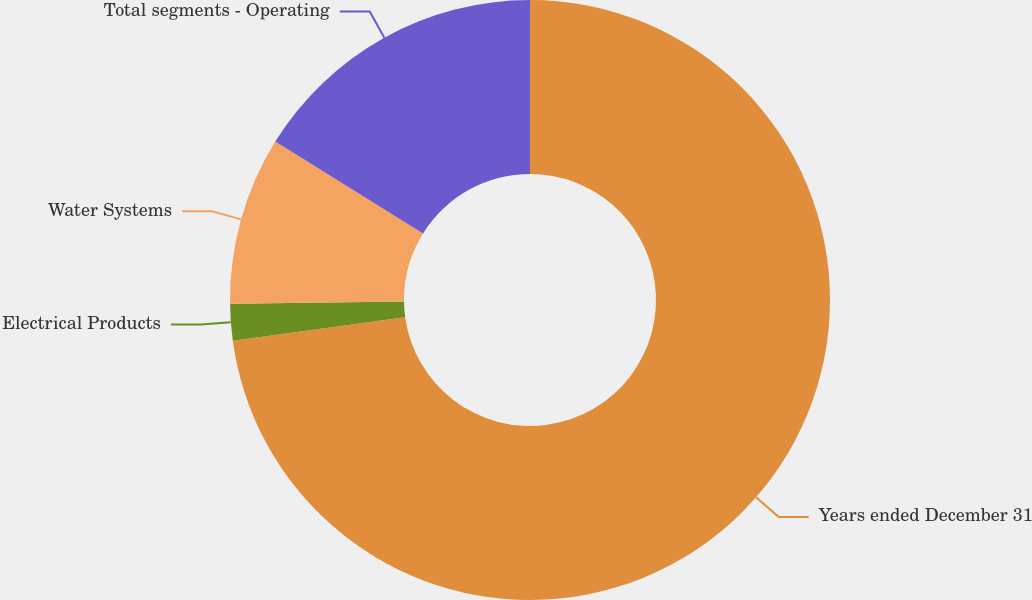Convert chart to OTSL. <chart><loc_0><loc_0><loc_500><loc_500><pie_chart><fcel>Years ended December 31<fcel>Electrical Products<fcel>Water Systems<fcel>Total segments - Operating<nl><fcel>72.83%<fcel>1.97%<fcel>9.06%<fcel>16.14%<nl></chart> 